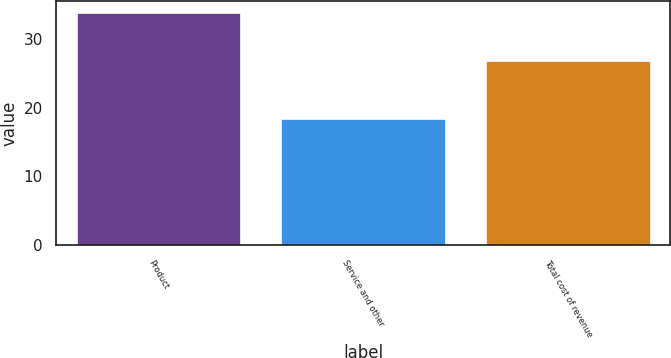<chart> <loc_0><loc_0><loc_500><loc_500><bar_chart><fcel>Product<fcel>Service and other<fcel>Total cost of revenue<nl><fcel>33.8<fcel>18.4<fcel>26.8<nl></chart> 